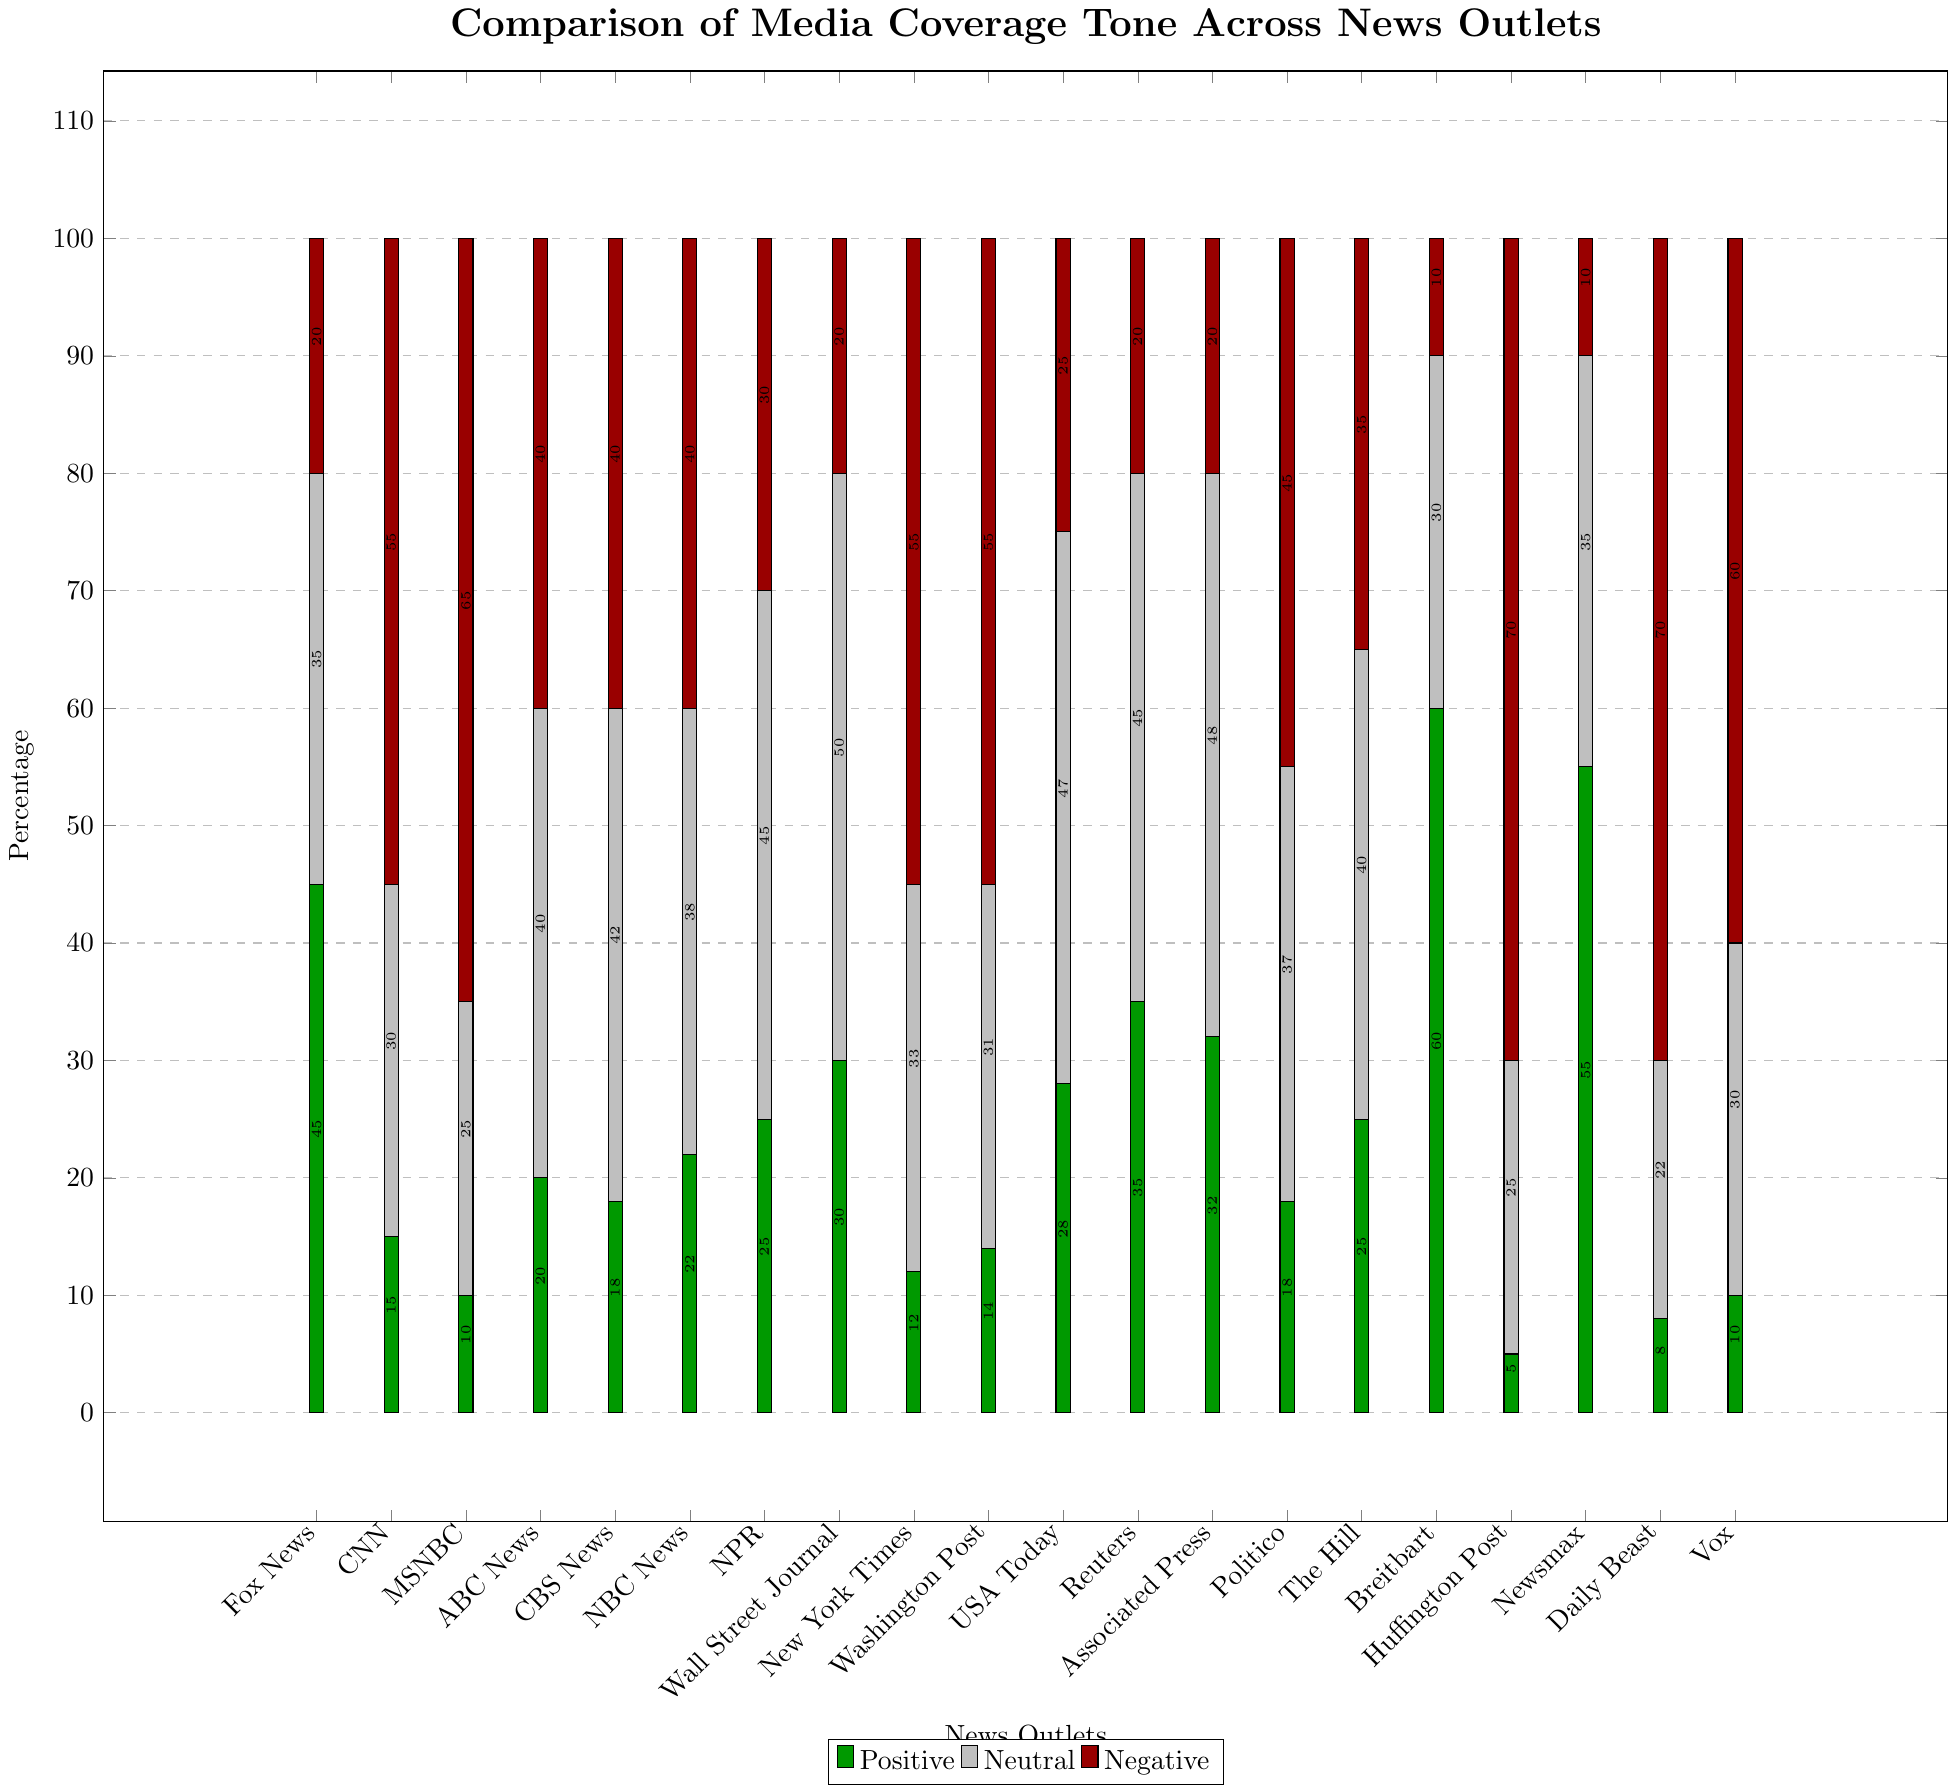What's the news outlet with the highest positive coverage? The figure visually shows that Breitbart has the tallest green bar, which represents positive coverage.
Answer: Breitbart Which news outlet has the highest negative coverage? By observing the height of the red bars, Huffington Post and Daily Beast have the tallest red bars, each at 70%.
Answer: Huffington Post and Daily Beast What is the sum of neutral coverage percentages for NPR and Wall Street Journal? NPR's neutral coverage percentage is 45%, and Wall Street Journal's is 50%. Adding them together gives 45 + 50 = 95%.
Answer: 95% Compare the total positive and negative coverage percentages for CNN. Which is larger? CNN's positive coverage is 15%, and its negative coverage is 55%. Comparing these values, 55% is larger than 15%.
Answer: Negative coverage Which news outlet has the smallest neutral coverage? By examining the height of the gray bars, Daily Beast has the shortest neutral bar, indicating the smallest neutral coverage percentage of 22%.
Answer: Daily Beast Which three news outlets have a balanced (equal) percentage of negative and neutral coverage? Looking at the bars where red and gray segments are of equal height, ABC News, CBS News, and NBC News each have 40% for both negative and neutral coverage.
Answer: ABC News, CBS News, and NBC News What is the average positive coverage percentage across all news outlets? Summing the positive coverage percentages across all news outlets (45, 15, 10, 20, 18, 22, 25, 30, 12, 14, 28, 35, 32, 18, 25, 60, 5, 55, 8, 10) gives 487. There are 20 news outlets, so the average is 487 / 20 = 24.35%.
Answer: 24.35% How does Fox News' total coverage percentage (sum of positive, neutral, and negative) compare to that of NPR? Fox News' total coverage percentage is 45% (positive) + 35% (neutral) + 20% (negative) = 100%. NPR's total coverage percentage is 25% (positive) + 45% (neutral) + 30% (negative) = 100%. Both totals are equal at 100%.
Answer: Equal 